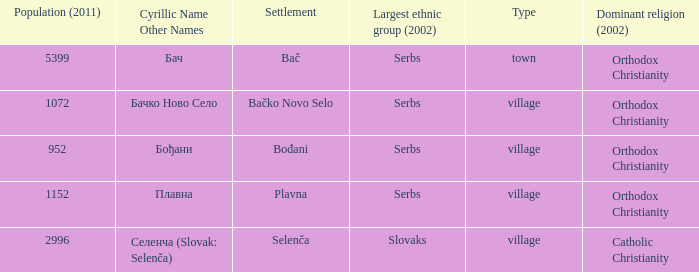What is the ethnic majority in the only town? Serbs. 